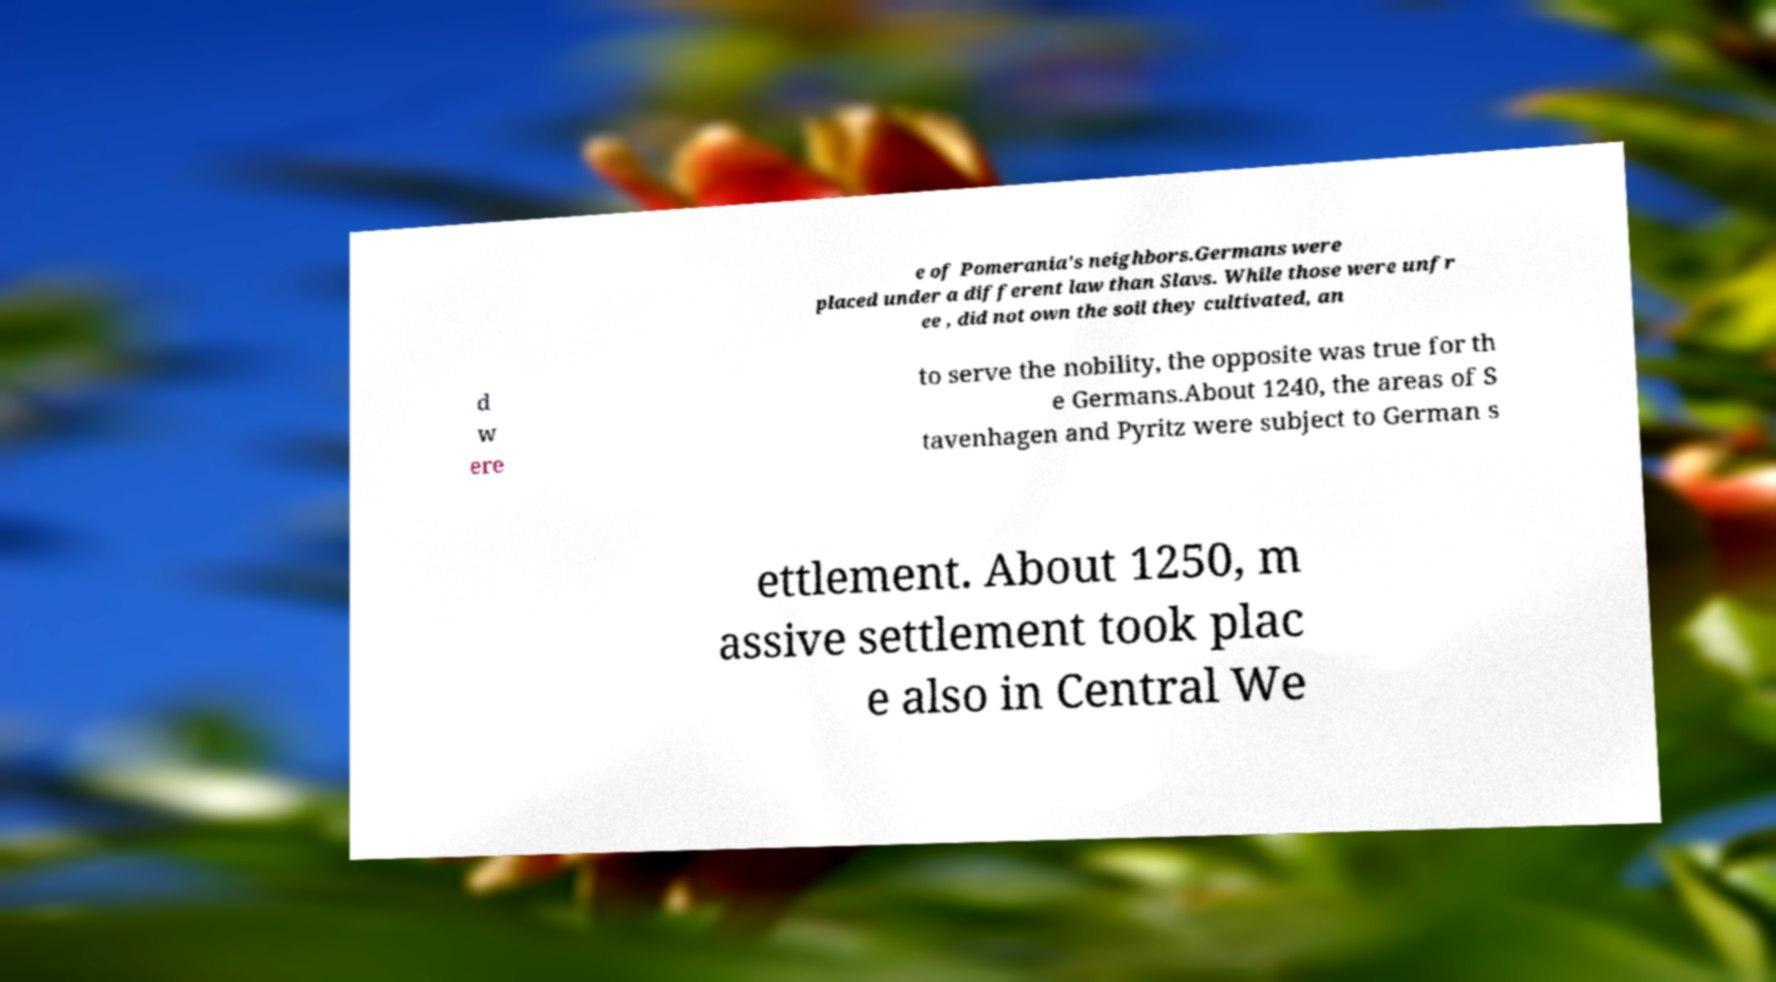I need the written content from this picture converted into text. Can you do that? e of Pomerania's neighbors.Germans were placed under a different law than Slavs. While those were unfr ee , did not own the soil they cultivated, an d w ere to serve the nobility, the opposite was true for th e Germans.About 1240, the areas of S tavenhagen and Pyritz were subject to German s ettlement. About 1250, m assive settlement took plac e also in Central We 